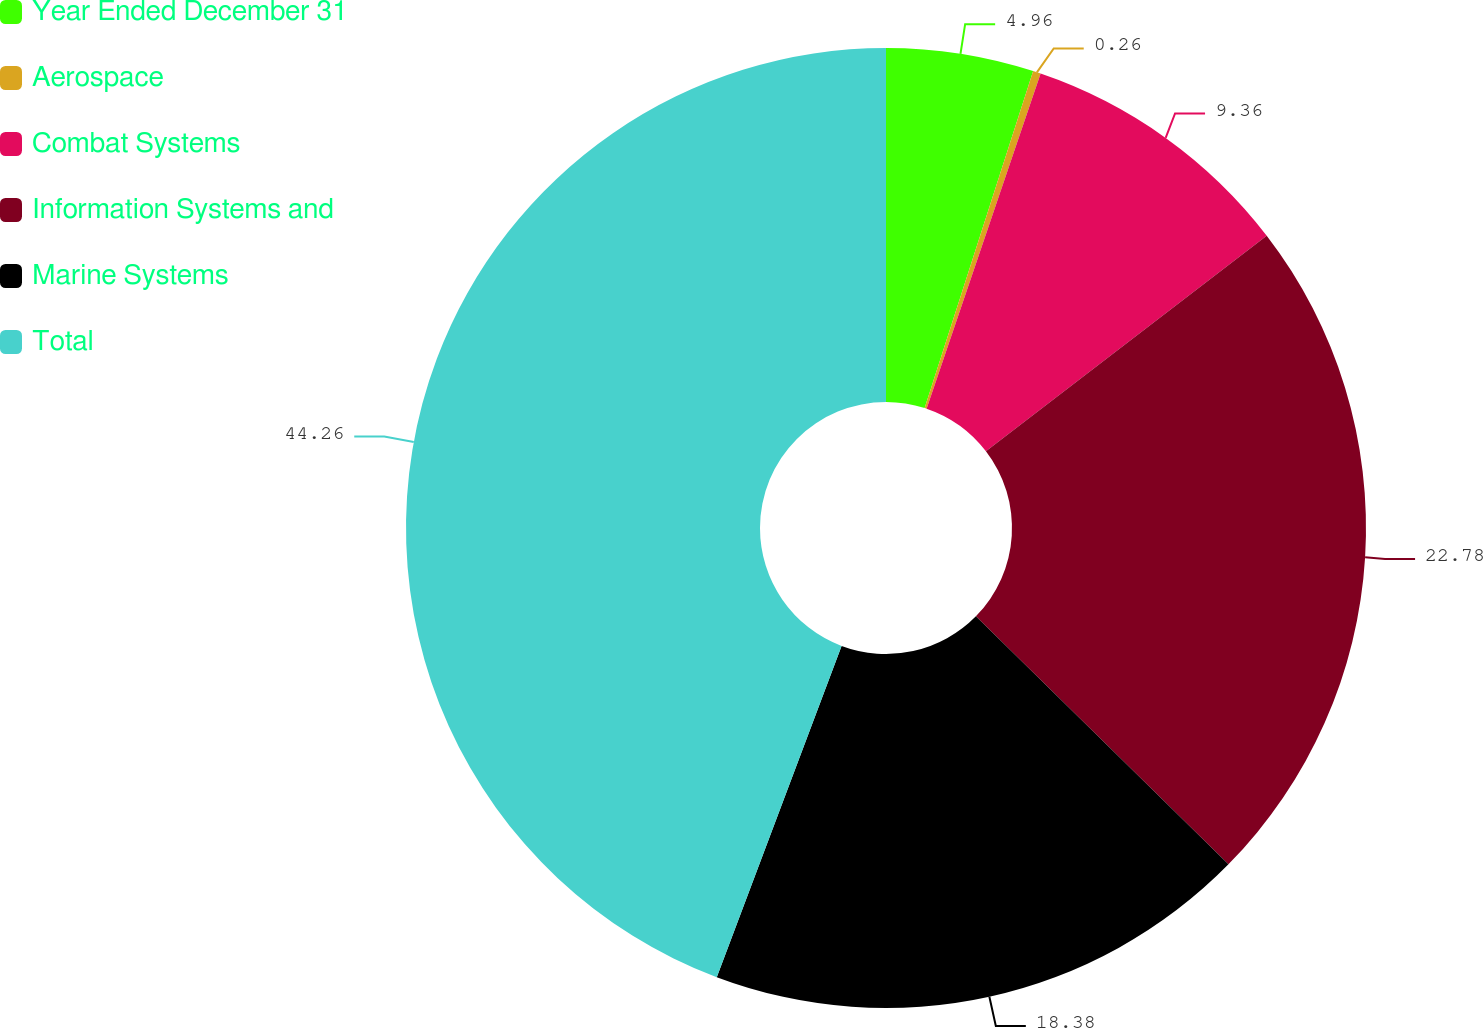Convert chart to OTSL. <chart><loc_0><loc_0><loc_500><loc_500><pie_chart><fcel>Year Ended December 31<fcel>Aerospace<fcel>Combat Systems<fcel>Information Systems and<fcel>Marine Systems<fcel>Total<nl><fcel>4.96%<fcel>0.26%<fcel>9.36%<fcel>22.78%<fcel>18.38%<fcel>44.27%<nl></chart> 